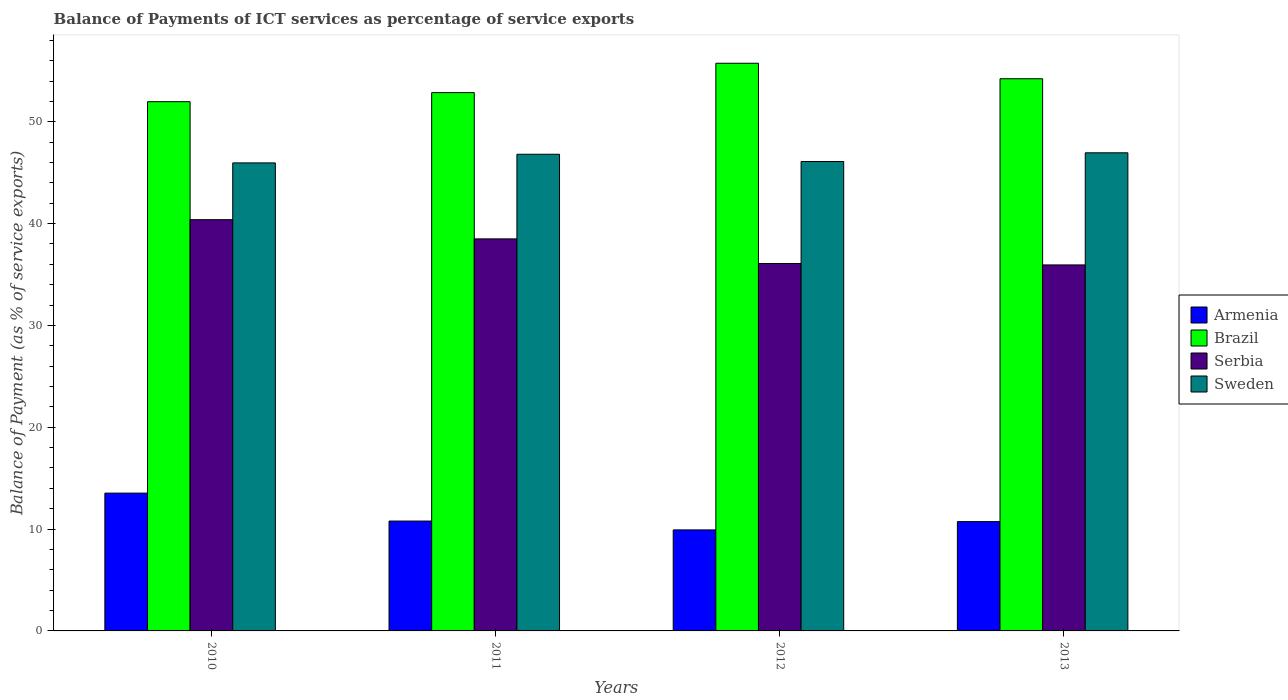How many different coloured bars are there?
Your answer should be very brief. 4. Are the number of bars per tick equal to the number of legend labels?
Make the answer very short. Yes. In how many cases, is the number of bars for a given year not equal to the number of legend labels?
Your answer should be compact. 0. What is the balance of payments of ICT services in Armenia in 2012?
Your answer should be very brief. 9.92. Across all years, what is the maximum balance of payments of ICT services in Serbia?
Offer a very short reply. 40.39. Across all years, what is the minimum balance of payments of ICT services in Armenia?
Your answer should be compact. 9.92. What is the total balance of payments of ICT services in Armenia in the graph?
Give a very brief answer. 44.98. What is the difference between the balance of payments of ICT services in Brazil in 2012 and that in 2013?
Your answer should be compact. 1.52. What is the difference between the balance of payments of ICT services in Sweden in 2012 and the balance of payments of ICT services in Brazil in 2013?
Give a very brief answer. -8.13. What is the average balance of payments of ICT services in Sweden per year?
Make the answer very short. 46.46. In the year 2012, what is the difference between the balance of payments of ICT services in Serbia and balance of payments of ICT services in Brazil?
Your answer should be compact. -19.67. What is the ratio of the balance of payments of ICT services in Sweden in 2011 to that in 2013?
Offer a terse response. 1. Is the balance of payments of ICT services in Serbia in 2011 less than that in 2013?
Give a very brief answer. No. What is the difference between the highest and the second highest balance of payments of ICT services in Sweden?
Offer a terse response. 0.14. What is the difference between the highest and the lowest balance of payments of ICT services in Serbia?
Offer a terse response. 4.45. Is it the case that in every year, the sum of the balance of payments of ICT services in Brazil and balance of payments of ICT services in Sweden is greater than the sum of balance of payments of ICT services in Serbia and balance of payments of ICT services in Armenia?
Give a very brief answer. No. What does the 2nd bar from the right in 2013 represents?
Offer a very short reply. Serbia. Is it the case that in every year, the sum of the balance of payments of ICT services in Brazil and balance of payments of ICT services in Armenia is greater than the balance of payments of ICT services in Sweden?
Your answer should be compact. Yes. How many bars are there?
Make the answer very short. 16. How many years are there in the graph?
Your answer should be compact. 4. What is the difference between two consecutive major ticks on the Y-axis?
Keep it short and to the point. 10. Where does the legend appear in the graph?
Keep it short and to the point. Center right. How are the legend labels stacked?
Your answer should be very brief. Vertical. What is the title of the graph?
Ensure brevity in your answer.  Balance of Payments of ICT services as percentage of service exports. What is the label or title of the X-axis?
Give a very brief answer. Years. What is the label or title of the Y-axis?
Offer a very short reply. Balance of Payment (as % of service exports). What is the Balance of Payment (as % of service exports) in Armenia in 2010?
Offer a terse response. 13.53. What is the Balance of Payment (as % of service exports) in Brazil in 2010?
Keep it short and to the point. 51.97. What is the Balance of Payment (as % of service exports) in Serbia in 2010?
Ensure brevity in your answer.  40.39. What is the Balance of Payment (as % of service exports) in Sweden in 2010?
Your answer should be very brief. 45.96. What is the Balance of Payment (as % of service exports) of Armenia in 2011?
Offer a very short reply. 10.79. What is the Balance of Payment (as % of service exports) of Brazil in 2011?
Provide a succinct answer. 52.86. What is the Balance of Payment (as % of service exports) in Serbia in 2011?
Give a very brief answer. 38.5. What is the Balance of Payment (as % of service exports) of Sweden in 2011?
Offer a very short reply. 46.81. What is the Balance of Payment (as % of service exports) of Armenia in 2012?
Keep it short and to the point. 9.92. What is the Balance of Payment (as % of service exports) of Brazil in 2012?
Ensure brevity in your answer.  55.75. What is the Balance of Payment (as % of service exports) of Serbia in 2012?
Ensure brevity in your answer.  36.08. What is the Balance of Payment (as % of service exports) of Sweden in 2012?
Ensure brevity in your answer.  46.1. What is the Balance of Payment (as % of service exports) of Armenia in 2013?
Provide a succinct answer. 10.73. What is the Balance of Payment (as % of service exports) in Brazil in 2013?
Offer a terse response. 54.23. What is the Balance of Payment (as % of service exports) of Serbia in 2013?
Provide a short and direct response. 35.94. What is the Balance of Payment (as % of service exports) in Sweden in 2013?
Keep it short and to the point. 46.95. Across all years, what is the maximum Balance of Payment (as % of service exports) of Armenia?
Your answer should be compact. 13.53. Across all years, what is the maximum Balance of Payment (as % of service exports) in Brazil?
Offer a very short reply. 55.75. Across all years, what is the maximum Balance of Payment (as % of service exports) in Serbia?
Offer a terse response. 40.39. Across all years, what is the maximum Balance of Payment (as % of service exports) of Sweden?
Offer a very short reply. 46.95. Across all years, what is the minimum Balance of Payment (as % of service exports) in Armenia?
Offer a very short reply. 9.92. Across all years, what is the minimum Balance of Payment (as % of service exports) of Brazil?
Give a very brief answer. 51.97. Across all years, what is the minimum Balance of Payment (as % of service exports) of Serbia?
Your answer should be very brief. 35.94. Across all years, what is the minimum Balance of Payment (as % of service exports) in Sweden?
Ensure brevity in your answer.  45.96. What is the total Balance of Payment (as % of service exports) of Armenia in the graph?
Make the answer very short. 44.98. What is the total Balance of Payment (as % of service exports) in Brazil in the graph?
Ensure brevity in your answer.  214.81. What is the total Balance of Payment (as % of service exports) of Serbia in the graph?
Give a very brief answer. 150.91. What is the total Balance of Payment (as % of service exports) in Sweden in the graph?
Offer a terse response. 185.82. What is the difference between the Balance of Payment (as % of service exports) in Armenia in 2010 and that in 2011?
Give a very brief answer. 2.74. What is the difference between the Balance of Payment (as % of service exports) of Brazil in 2010 and that in 2011?
Provide a succinct answer. -0.89. What is the difference between the Balance of Payment (as % of service exports) of Serbia in 2010 and that in 2011?
Your answer should be compact. 1.89. What is the difference between the Balance of Payment (as % of service exports) of Sweden in 2010 and that in 2011?
Your answer should be compact. -0.85. What is the difference between the Balance of Payment (as % of service exports) in Armenia in 2010 and that in 2012?
Give a very brief answer. 3.61. What is the difference between the Balance of Payment (as % of service exports) in Brazil in 2010 and that in 2012?
Your answer should be compact. -3.77. What is the difference between the Balance of Payment (as % of service exports) in Serbia in 2010 and that in 2012?
Keep it short and to the point. 4.31. What is the difference between the Balance of Payment (as % of service exports) in Sweden in 2010 and that in 2012?
Provide a succinct answer. -0.14. What is the difference between the Balance of Payment (as % of service exports) of Armenia in 2010 and that in 2013?
Provide a short and direct response. 2.8. What is the difference between the Balance of Payment (as % of service exports) of Brazil in 2010 and that in 2013?
Make the answer very short. -2.25. What is the difference between the Balance of Payment (as % of service exports) in Serbia in 2010 and that in 2013?
Give a very brief answer. 4.45. What is the difference between the Balance of Payment (as % of service exports) of Sweden in 2010 and that in 2013?
Provide a short and direct response. -0.99. What is the difference between the Balance of Payment (as % of service exports) in Armenia in 2011 and that in 2012?
Offer a very short reply. 0.87. What is the difference between the Balance of Payment (as % of service exports) in Brazil in 2011 and that in 2012?
Your answer should be compact. -2.88. What is the difference between the Balance of Payment (as % of service exports) in Serbia in 2011 and that in 2012?
Offer a very short reply. 2.42. What is the difference between the Balance of Payment (as % of service exports) in Sweden in 2011 and that in 2012?
Offer a terse response. 0.71. What is the difference between the Balance of Payment (as % of service exports) of Armenia in 2011 and that in 2013?
Your response must be concise. 0.05. What is the difference between the Balance of Payment (as % of service exports) in Brazil in 2011 and that in 2013?
Your answer should be compact. -1.36. What is the difference between the Balance of Payment (as % of service exports) of Serbia in 2011 and that in 2013?
Provide a succinct answer. 2.56. What is the difference between the Balance of Payment (as % of service exports) in Sweden in 2011 and that in 2013?
Provide a succinct answer. -0.14. What is the difference between the Balance of Payment (as % of service exports) in Armenia in 2012 and that in 2013?
Make the answer very short. -0.81. What is the difference between the Balance of Payment (as % of service exports) of Brazil in 2012 and that in 2013?
Offer a very short reply. 1.52. What is the difference between the Balance of Payment (as % of service exports) in Serbia in 2012 and that in 2013?
Make the answer very short. 0.14. What is the difference between the Balance of Payment (as % of service exports) of Sweden in 2012 and that in 2013?
Offer a terse response. -0.85. What is the difference between the Balance of Payment (as % of service exports) in Armenia in 2010 and the Balance of Payment (as % of service exports) in Brazil in 2011?
Your response must be concise. -39.33. What is the difference between the Balance of Payment (as % of service exports) of Armenia in 2010 and the Balance of Payment (as % of service exports) of Serbia in 2011?
Keep it short and to the point. -24.97. What is the difference between the Balance of Payment (as % of service exports) in Armenia in 2010 and the Balance of Payment (as % of service exports) in Sweden in 2011?
Offer a very short reply. -33.28. What is the difference between the Balance of Payment (as % of service exports) in Brazil in 2010 and the Balance of Payment (as % of service exports) in Serbia in 2011?
Offer a terse response. 13.47. What is the difference between the Balance of Payment (as % of service exports) of Brazil in 2010 and the Balance of Payment (as % of service exports) of Sweden in 2011?
Your response must be concise. 5.16. What is the difference between the Balance of Payment (as % of service exports) of Serbia in 2010 and the Balance of Payment (as % of service exports) of Sweden in 2011?
Provide a short and direct response. -6.42. What is the difference between the Balance of Payment (as % of service exports) of Armenia in 2010 and the Balance of Payment (as % of service exports) of Brazil in 2012?
Offer a terse response. -42.21. What is the difference between the Balance of Payment (as % of service exports) in Armenia in 2010 and the Balance of Payment (as % of service exports) in Serbia in 2012?
Provide a succinct answer. -22.55. What is the difference between the Balance of Payment (as % of service exports) in Armenia in 2010 and the Balance of Payment (as % of service exports) in Sweden in 2012?
Offer a terse response. -32.57. What is the difference between the Balance of Payment (as % of service exports) of Brazil in 2010 and the Balance of Payment (as % of service exports) of Serbia in 2012?
Ensure brevity in your answer.  15.89. What is the difference between the Balance of Payment (as % of service exports) in Brazil in 2010 and the Balance of Payment (as % of service exports) in Sweden in 2012?
Give a very brief answer. 5.87. What is the difference between the Balance of Payment (as % of service exports) in Serbia in 2010 and the Balance of Payment (as % of service exports) in Sweden in 2012?
Make the answer very short. -5.71. What is the difference between the Balance of Payment (as % of service exports) in Armenia in 2010 and the Balance of Payment (as % of service exports) in Brazil in 2013?
Ensure brevity in your answer.  -40.69. What is the difference between the Balance of Payment (as % of service exports) in Armenia in 2010 and the Balance of Payment (as % of service exports) in Serbia in 2013?
Provide a succinct answer. -22.41. What is the difference between the Balance of Payment (as % of service exports) of Armenia in 2010 and the Balance of Payment (as % of service exports) of Sweden in 2013?
Keep it short and to the point. -33.42. What is the difference between the Balance of Payment (as % of service exports) of Brazil in 2010 and the Balance of Payment (as % of service exports) of Serbia in 2013?
Your response must be concise. 16.03. What is the difference between the Balance of Payment (as % of service exports) in Brazil in 2010 and the Balance of Payment (as % of service exports) in Sweden in 2013?
Your answer should be compact. 5.02. What is the difference between the Balance of Payment (as % of service exports) in Serbia in 2010 and the Balance of Payment (as % of service exports) in Sweden in 2013?
Your response must be concise. -6.57. What is the difference between the Balance of Payment (as % of service exports) in Armenia in 2011 and the Balance of Payment (as % of service exports) in Brazil in 2012?
Your response must be concise. -44.96. What is the difference between the Balance of Payment (as % of service exports) of Armenia in 2011 and the Balance of Payment (as % of service exports) of Serbia in 2012?
Offer a terse response. -25.29. What is the difference between the Balance of Payment (as % of service exports) of Armenia in 2011 and the Balance of Payment (as % of service exports) of Sweden in 2012?
Keep it short and to the point. -35.31. What is the difference between the Balance of Payment (as % of service exports) of Brazil in 2011 and the Balance of Payment (as % of service exports) of Serbia in 2012?
Provide a short and direct response. 16.78. What is the difference between the Balance of Payment (as % of service exports) in Brazil in 2011 and the Balance of Payment (as % of service exports) in Sweden in 2012?
Your answer should be compact. 6.76. What is the difference between the Balance of Payment (as % of service exports) of Serbia in 2011 and the Balance of Payment (as % of service exports) of Sweden in 2012?
Your answer should be very brief. -7.6. What is the difference between the Balance of Payment (as % of service exports) in Armenia in 2011 and the Balance of Payment (as % of service exports) in Brazil in 2013?
Your response must be concise. -43.44. What is the difference between the Balance of Payment (as % of service exports) of Armenia in 2011 and the Balance of Payment (as % of service exports) of Serbia in 2013?
Your response must be concise. -25.15. What is the difference between the Balance of Payment (as % of service exports) of Armenia in 2011 and the Balance of Payment (as % of service exports) of Sweden in 2013?
Ensure brevity in your answer.  -36.16. What is the difference between the Balance of Payment (as % of service exports) of Brazil in 2011 and the Balance of Payment (as % of service exports) of Serbia in 2013?
Ensure brevity in your answer.  16.92. What is the difference between the Balance of Payment (as % of service exports) of Brazil in 2011 and the Balance of Payment (as % of service exports) of Sweden in 2013?
Make the answer very short. 5.91. What is the difference between the Balance of Payment (as % of service exports) of Serbia in 2011 and the Balance of Payment (as % of service exports) of Sweden in 2013?
Provide a short and direct response. -8.45. What is the difference between the Balance of Payment (as % of service exports) in Armenia in 2012 and the Balance of Payment (as % of service exports) in Brazil in 2013?
Ensure brevity in your answer.  -44.3. What is the difference between the Balance of Payment (as % of service exports) of Armenia in 2012 and the Balance of Payment (as % of service exports) of Serbia in 2013?
Provide a succinct answer. -26.02. What is the difference between the Balance of Payment (as % of service exports) of Armenia in 2012 and the Balance of Payment (as % of service exports) of Sweden in 2013?
Provide a succinct answer. -37.03. What is the difference between the Balance of Payment (as % of service exports) of Brazil in 2012 and the Balance of Payment (as % of service exports) of Serbia in 2013?
Give a very brief answer. 19.8. What is the difference between the Balance of Payment (as % of service exports) in Brazil in 2012 and the Balance of Payment (as % of service exports) in Sweden in 2013?
Make the answer very short. 8.79. What is the difference between the Balance of Payment (as % of service exports) in Serbia in 2012 and the Balance of Payment (as % of service exports) in Sweden in 2013?
Provide a succinct answer. -10.87. What is the average Balance of Payment (as % of service exports) in Armenia per year?
Your answer should be very brief. 11.24. What is the average Balance of Payment (as % of service exports) in Brazil per year?
Make the answer very short. 53.7. What is the average Balance of Payment (as % of service exports) of Serbia per year?
Provide a short and direct response. 37.73. What is the average Balance of Payment (as % of service exports) in Sweden per year?
Offer a terse response. 46.46. In the year 2010, what is the difference between the Balance of Payment (as % of service exports) of Armenia and Balance of Payment (as % of service exports) of Brazil?
Provide a succinct answer. -38.44. In the year 2010, what is the difference between the Balance of Payment (as % of service exports) in Armenia and Balance of Payment (as % of service exports) in Serbia?
Ensure brevity in your answer.  -26.86. In the year 2010, what is the difference between the Balance of Payment (as % of service exports) in Armenia and Balance of Payment (as % of service exports) in Sweden?
Keep it short and to the point. -32.43. In the year 2010, what is the difference between the Balance of Payment (as % of service exports) of Brazil and Balance of Payment (as % of service exports) of Serbia?
Make the answer very short. 11.58. In the year 2010, what is the difference between the Balance of Payment (as % of service exports) of Brazil and Balance of Payment (as % of service exports) of Sweden?
Offer a very short reply. 6.01. In the year 2010, what is the difference between the Balance of Payment (as % of service exports) of Serbia and Balance of Payment (as % of service exports) of Sweden?
Ensure brevity in your answer.  -5.57. In the year 2011, what is the difference between the Balance of Payment (as % of service exports) in Armenia and Balance of Payment (as % of service exports) in Brazil?
Your answer should be compact. -42.08. In the year 2011, what is the difference between the Balance of Payment (as % of service exports) in Armenia and Balance of Payment (as % of service exports) in Serbia?
Your response must be concise. -27.71. In the year 2011, what is the difference between the Balance of Payment (as % of service exports) of Armenia and Balance of Payment (as % of service exports) of Sweden?
Give a very brief answer. -36.02. In the year 2011, what is the difference between the Balance of Payment (as % of service exports) in Brazil and Balance of Payment (as % of service exports) in Serbia?
Your response must be concise. 14.37. In the year 2011, what is the difference between the Balance of Payment (as % of service exports) of Brazil and Balance of Payment (as % of service exports) of Sweden?
Your answer should be compact. 6.05. In the year 2011, what is the difference between the Balance of Payment (as % of service exports) in Serbia and Balance of Payment (as % of service exports) in Sweden?
Your answer should be very brief. -8.31. In the year 2012, what is the difference between the Balance of Payment (as % of service exports) in Armenia and Balance of Payment (as % of service exports) in Brazil?
Your answer should be very brief. -45.83. In the year 2012, what is the difference between the Balance of Payment (as % of service exports) of Armenia and Balance of Payment (as % of service exports) of Serbia?
Your answer should be compact. -26.16. In the year 2012, what is the difference between the Balance of Payment (as % of service exports) of Armenia and Balance of Payment (as % of service exports) of Sweden?
Your answer should be compact. -36.18. In the year 2012, what is the difference between the Balance of Payment (as % of service exports) in Brazil and Balance of Payment (as % of service exports) in Serbia?
Make the answer very short. 19.67. In the year 2012, what is the difference between the Balance of Payment (as % of service exports) in Brazil and Balance of Payment (as % of service exports) in Sweden?
Keep it short and to the point. 9.65. In the year 2012, what is the difference between the Balance of Payment (as % of service exports) of Serbia and Balance of Payment (as % of service exports) of Sweden?
Offer a terse response. -10.02. In the year 2013, what is the difference between the Balance of Payment (as % of service exports) of Armenia and Balance of Payment (as % of service exports) of Brazil?
Offer a very short reply. -43.49. In the year 2013, what is the difference between the Balance of Payment (as % of service exports) of Armenia and Balance of Payment (as % of service exports) of Serbia?
Your answer should be very brief. -25.21. In the year 2013, what is the difference between the Balance of Payment (as % of service exports) in Armenia and Balance of Payment (as % of service exports) in Sweden?
Offer a terse response. -36.22. In the year 2013, what is the difference between the Balance of Payment (as % of service exports) of Brazil and Balance of Payment (as % of service exports) of Serbia?
Ensure brevity in your answer.  18.28. In the year 2013, what is the difference between the Balance of Payment (as % of service exports) in Brazil and Balance of Payment (as % of service exports) in Sweden?
Your answer should be very brief. 7.27. In the year 2013, what is the difference between the Balance of Payment (as % of service exports) of Serbia and Balance of Payment (as % of service exports) of Sweden?
Make the answer very short. -11.01. What is the ratio of the Balance of Payment (as % of service exports) of Armenia in 2010 to that in 2011?
Offer a terse response. 1.25. What is the ratio of the Balance of Payment (as % of service exports) of Brazil in 2010 to that in 2011?
Your answer should be compact. 0.98. What is the ratio of the Balance of Payment (as % of service exports) in Serbia in 2010 to that in 2011?
Offer a terse response. 1.05. What is the ratio of the Balance of Payment (as % of service exports) of Sweden in 2010 to that in 2011?
Give a very brief answer. 0.98. What is the ratio of the Balance of Payment (as % of service exports) in Armenia in 2010 to that in 2012?
Give a very brief answer. 1.36. What is the ratio of the Balance of Payment (as % of service exports) in Brazil in 2010 to that in 2012?
Provide a succinct answer. 0.93. What is the ratio of the Balance of Payment (as % of service exports) in Serbia in 2010 to that in 2012?
Make the answer very short. 1.12. What is the ratio of the Balance of Payment (as % of service exports) of Armenia in 2010 to that in 2013?
Offer a very short reply. 1.26. What is the ratio of the Balance of Payment (as % of service exports) in Brazil in 2010 to that in 2013?
Keep it short and to the point. 0.96. What is the ratio of the Balance of Payment (as % of service exports) in Serbia in 2010 to that in 2013?
Provide a succinct answer. 1.12. What is the ratio of the Balance of Payment (as % of service exports) of Sweden in 2010 to that in 2013?
Make the answer very short. 0.98. What is the ratio of the Balance of Payment (as % of service exports) in Armenia in 2011 to that in 2012?
Offer a terse response. 1.09. What is the ratio of the Balance of Payment (as % of service exports) of Brazil in 2011 to that in 2012?
Your answer should be compact. 0.95. What is the ratio of the Balance of Payment (as % of service exports) of Serbia in 2011 to that in 2012?
Offer a very short reply. 1.07. What is the ratio of the Balance of Payment (as % of service exports) of Sweden in 2011 to that in 2012?
Keep it short and to the point. 1.02. What is the ratio of the Balance of Payment (as % of service exports) in Armenia in 2011 to that in 2013?
Give a very brief answer. 1.01. What is the ratio of the Balance of Payment (as % of service exports) of Brazil in 2011 to that in 2013?
Offer a very short reply. 0.97. What is the ratio of the Balance of Payment (as % of service exports) in Serbia in 2011 to that in 2013?
Provide a short and direct response. 1.07. What is the ratio of the Balance of Payment (as % of service exports) of Armenia in 2012 to that in 2013?
Give a very brief answer. 0.92. What is the ratio of the Balance of Payment (as % of service exports) of Brazil in 2012 to that in 2013?
Provide a succinct answer. 1.03. What is the ratio of the Balance of Payment (as % of service exports) of Sweden in 2012 to that in 2013?
Provide a short and direct response. 0.98. What is the difference between the highest and the second highest Balance of Payment (as % of service exports) in Armenia?
Offer a very short reply. 2.74. What is the difference between the highest and the second highest Balance of Payment (as % of service exports) of Brazil?
Provide a succinct answer. 1.52. What is the difference between the highest and the second highest Balance of Payment (as % of service exports) of Serbia?
Keep it short and to the point. 1.89. What is the difference between the highest and the second highest Balance of Payment (as % of service exports) in Sweden?
Your answer should be compact. 0.14. What is the difference between the highest and the lowest Balance of Payment (as % of service exports) in Armenia?
Make the answer very short. 3.61. What is the difference between the highest and the lowest Balance of Payment (as % of service exports) of Brazil?
Ensure brevity in your answer.  3.77. What is the difference between the highest and the lowest Balance of Payment (as % of service exports) of Serbia?
Your response must be concise. 4.45. 